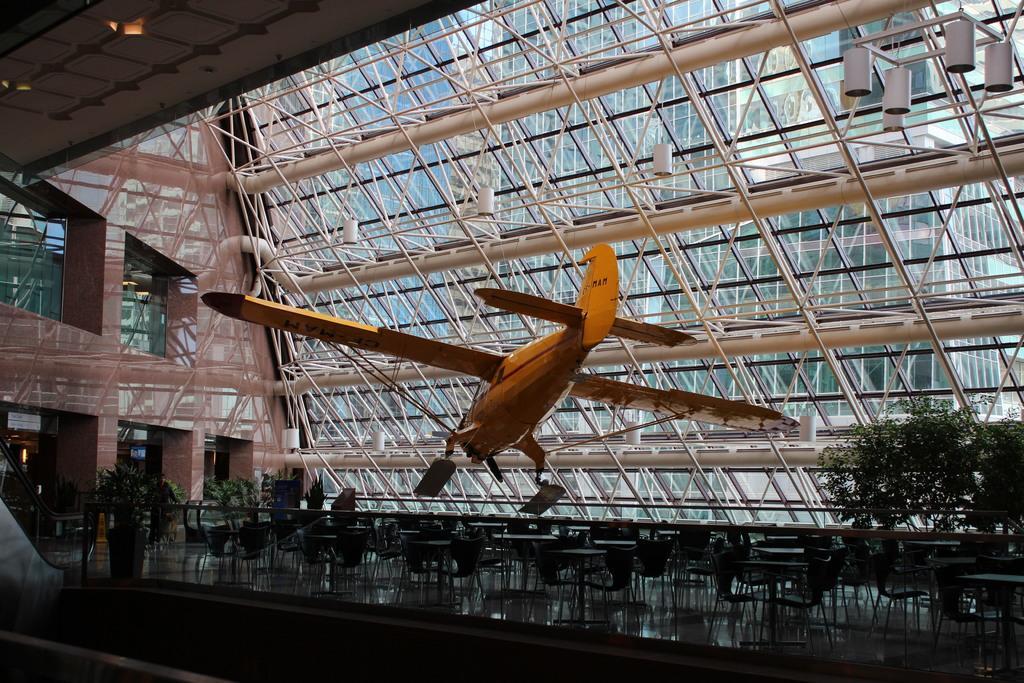Can you describe this image briefly? In this picture there is a dummy plane which is hanging from the roof. At the bottom I can see many chairs and tables. Beside that I can see plants and pots. On the top right corner I can see some lights which are placed on the roof. In the back I can see the buildings, windows, steel pipes and other objects. On the left I can see the sign board which is placed near to the door. 